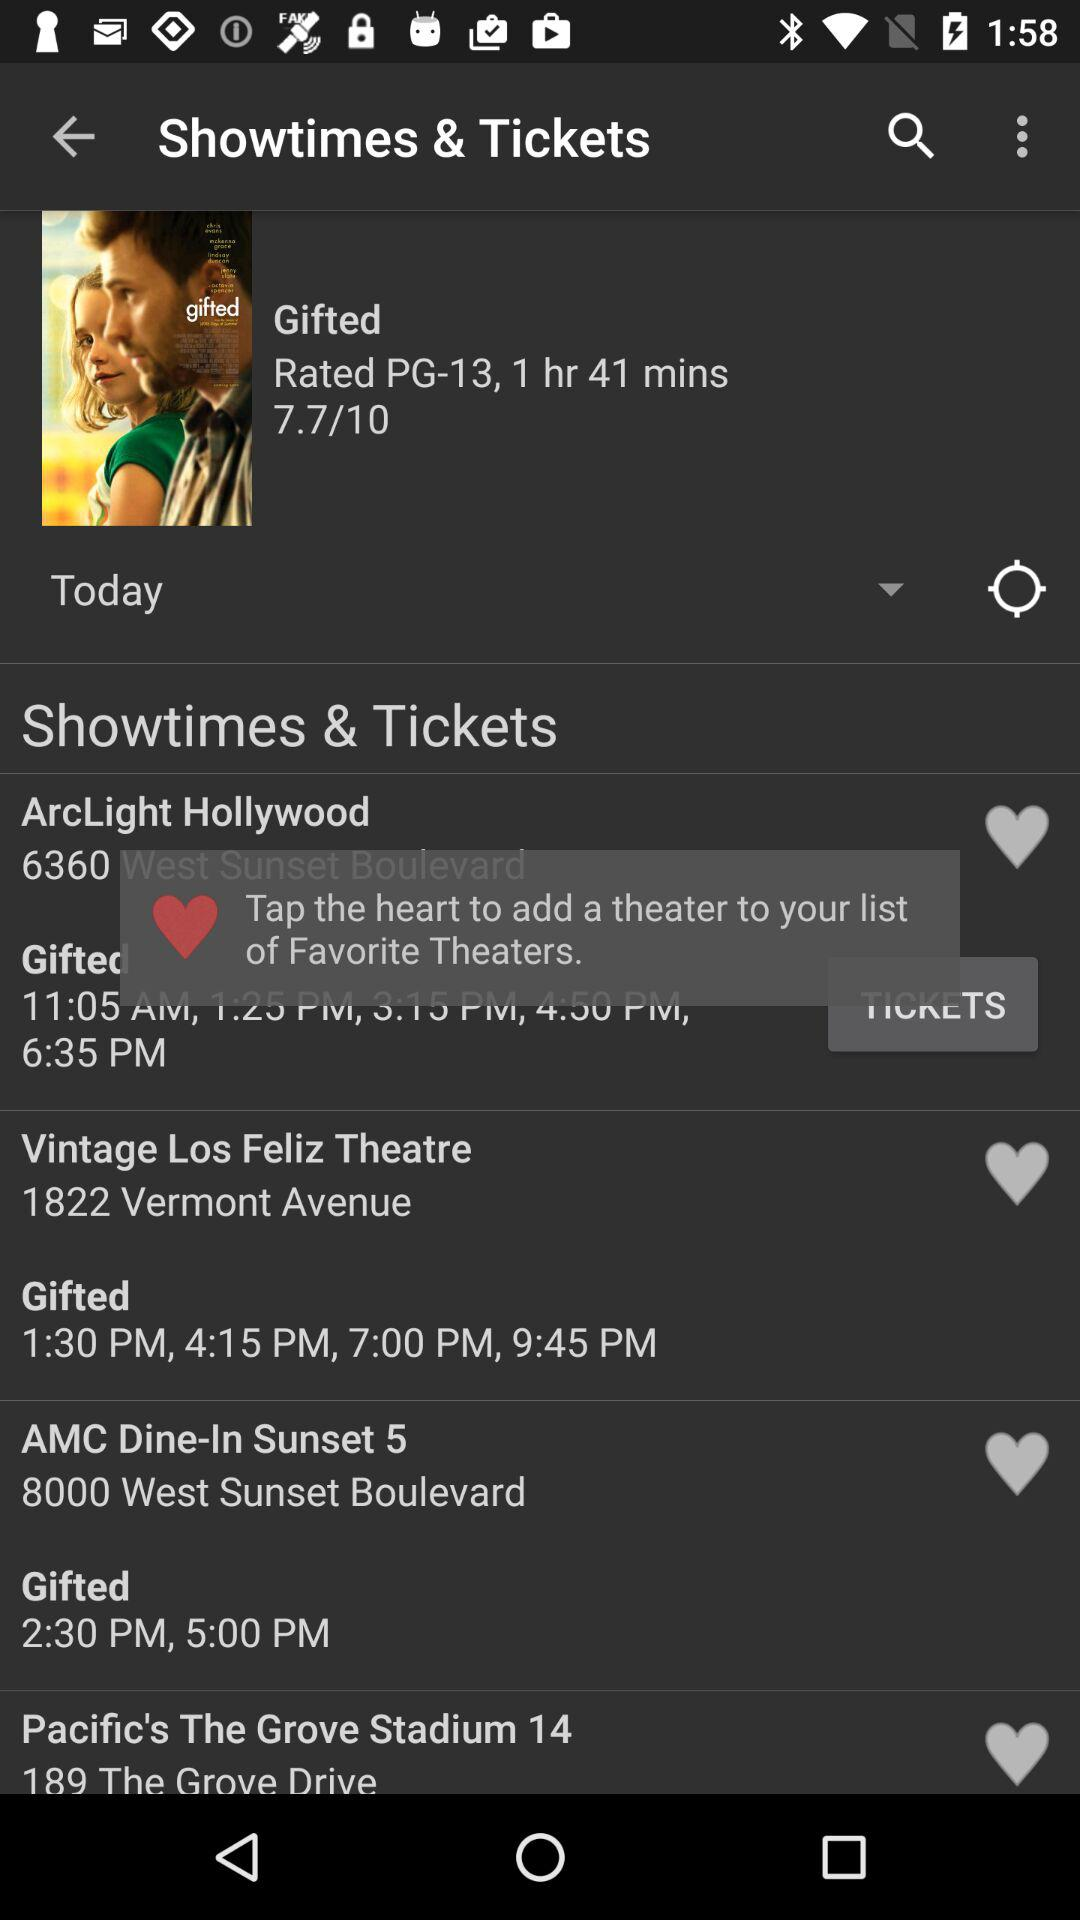What is the rating of the movie? The rating of the movie is 7.7. 